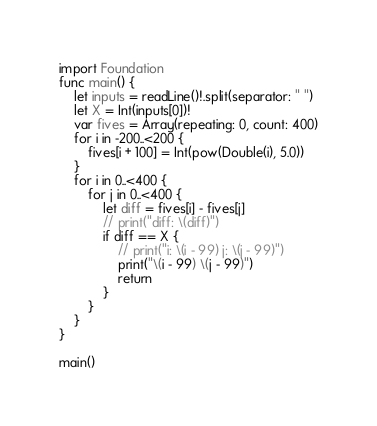<code> <loc_0><loc_0><loc_500><loc_500><_Swift_>import Foundation
func main() {
    let inputs = readLine()!.split(separator: " ")
    let X = Int(inputs[0])!
    var fives = Array(repeating: 0, count: 400)
    for i in -200..<200 {
        fives[i + 100] = Int(pow(Double(i), 5.0))
    }
    for i in 0..<400 {
        for j in 0..<400 {
            let diff = fives[i] - fives[j]
            // print("diff: \(diff)")
            if diff == X {
                // print("i: \(i - 99) j: \(j - 99)")
                print("\(i - 99) \(j - 99)")
                return
            }
        }
    }
}

main()</code> 